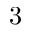Convert formula to latex. <formula><loc_0><loc_0><loc_500><loc_500>3</formula> 